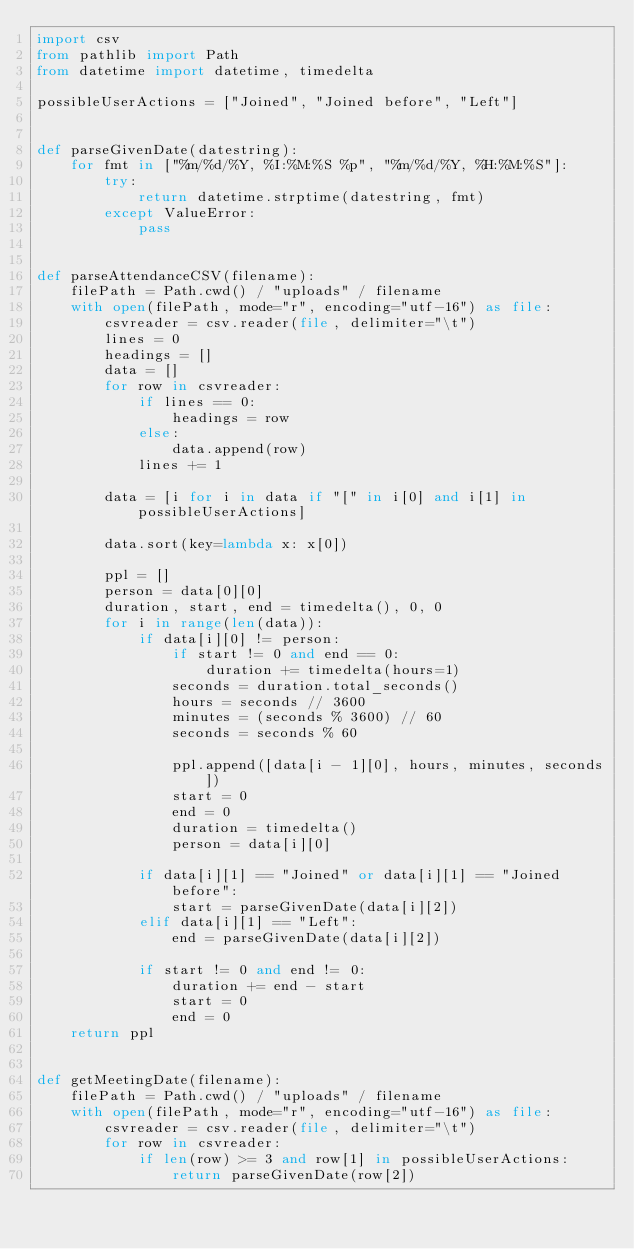Convert code to text. <code><loc_0><loc_0><loc_500><loc_500><_Python_>import csv
from pathlib import Path
from datetime import datetime, timedelta

possibleUserActions = ["Joined", "Joined before", "Left"]


def parseGivenDate(datestring):
    for fmt in ["%m/%d/%Y, %I:%M:%S %p", "%m/%d/%Y, %H:%M:%S"]:
        try:
            return datetime.strptime(datestring, fmt)
        except ValueError:
            pass


def parseAttendanceCSV(filename):
    filePath = Path.cwd() / "uploads" / filename
    with open(filePath, mode="r", encoding="utf-16") as file:
        csvreader = csv.reader(file, delimiter="\t")
        lines = 0
        headings = []
        data = []
        for row in csvreader:
            if lines == 0:
                headings = row
            else:
                data.append(row)
            lines += 1

        data = [i for i in data if "[" in i[0] and i[1] in possibleUserActions]

        data.sort(key=lambda x: x[0])

        ppl = []
        person = data[0][0]
        duration, start, end = timedelta(), 0, 0
        for i in range(len(data)):
            if data[i][0] != person:
                if start != 0 and end == 0:
                    duration += timedelta(hours=1)
                seconds = duration.total_seconds()
                hours = seconds // 3600
                minutes = (seconds % 3600) // 60
                seconds = seconds % 60

                ppl.append([data[i - 1][0], hours, minutes, seconds])
                start = 0
                end = 0
                duration = timedelta()
                person = data[i][0]

            if data[i][1] == "Joined" or data[i][1] == "Joined before":
                start = parseGivenDate(data[i][2])
            elif data[i][1] == "Left":
                end = parseGivenDate(data[i][2])

            if start != 0 and end != 0:
                duration += end - start
                start = 0
                end = 0
    return ppl


def getMeetingDate(filename):
    filePath = Path.cwd() / "uploads" / filename
    with open(filePath, mode="r", encoding="utf-16") as file:
        csvreader = csv.reader(file, delimiter="\t")
        for row in csvreader:
            if len(row) >= 3 and row[1] in possibleUserActions:
                return parseGivenDate(row[2])</code> 